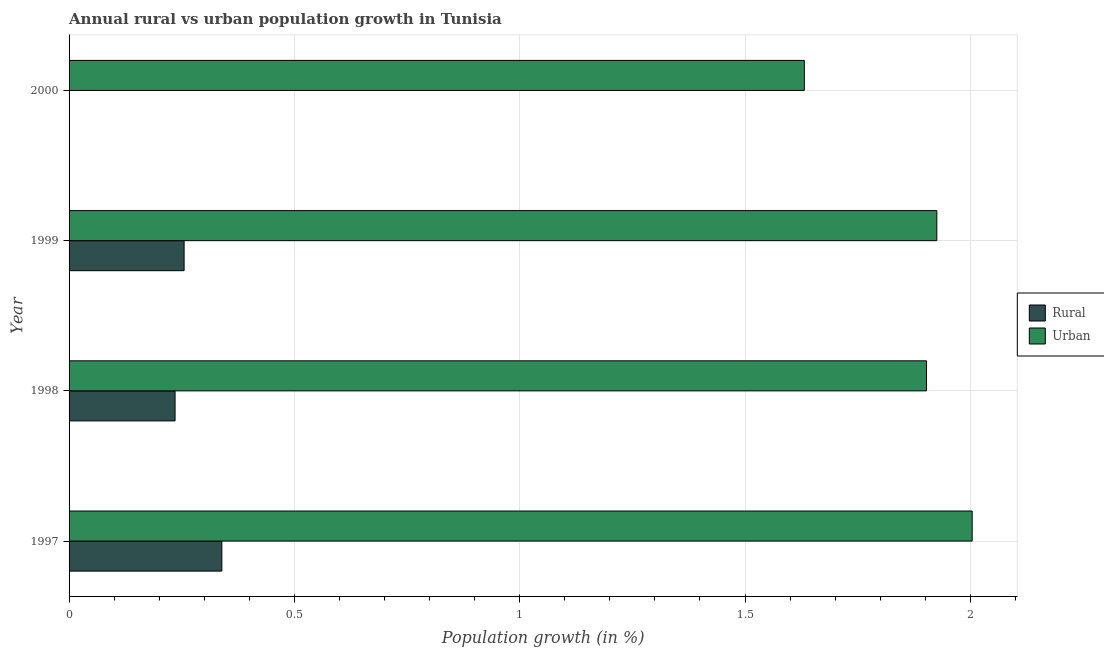Are the number of bars on each tick of the Y-axis equal?
Provide a succinct answer. No. How many bars are there on the 4th tick from the top?
Your answer should be very brief. 2. What is the rural population growth in 1999?
Your response must be concise. 0.26. Across all years, what is the maximum urban population growth?
Keep it short and to the point. 2. In which year was the rural population growth maximum?
Your answer should be compact. 1997. What is the total urban population growth in the graph?
Ensure brevity in your answer.  7.46. What is the difference between the urban population growth in 1998 and that in 1999?
Offer a terse response. -0.02. What is the difference between the urban population growth in 2000 and the rural population growth in 1999?
Make the answer very short. 1.38. What is the average rural population growth per year?
Ensure brevity in your answer.  0.21. In the year 1998, what is the difference between the urban population growth and rural population growth?
Give a very brief answer. 1.67. What is the ratio of the rural population growth in 1997 to that in 1998?
Give a very brief answer. 1.44. Is the urban population growth in 1998 less than that in 2000?
Offer a terse response. No. What is the difference between the highest and the second highest urban population growth?
Offer a very short reply. 0.08. What is the difference between the highest and the lowest urban population growth?
Make the answer very short. 0.37. How many years are there in the graph?
Your response must be concise. 4. Are the values on the major ticks of X-axis written in scientific E-notation?
Offer a terse response. No. Does the graph contain any zero values?
Keep it short and to the point. Yes. Does the graph contain grids?
Your answer should be compact. Yes. Where does the legend appear in the graph?
Ensure brevity in your answer.  Center right. How many legend labels are there?
Make the answer very short. 2. How are the legend labels stacked?
Your answer should be compact. Vertical. What is the title of the graph?
Offer a terse response. Annual rural vs urban population growth in Tunisia. Does "Lowest 20% of population" appear as one of the legend labels in the graph?
Provide a short and direct response. No. What is the label or title of the X-axis?
Your answer should be compact. Population growth (in %). What is the Population growth (in %) in Rural in 1997?
Offer a terse response. 0.34. What is the Population growth (in %) in Urban  in 1997?
Ensure brevity in your answer.  2. What is the Population growth (in %) of Rural in 1998?
Provide a succinct answer. 0.24. What is the Population growth (in %) of Urban  in 1998?
Ensure brevity in your answer.  1.9. What is the Population growth (in %) in Rural in 1999?
Your answer should be compact. 0.26. What is the Population growth (in %) in Urban  in 1999?
Make the answer very short. 1.93. What is the Population growth (in %) in Rural in 2000?
Ensure brevity in your answer.  0. What is the Population growth (in %) in Urban  in 2000?
Provide a short and direct response. 1.63. Across all years, what is the maximum Population growth (in %) in Rural?
Provide a succinct answer. 0.34. Across all years, what is the maximum Population growth (in %) in Urban ?
Keep it short and to the point. 2. Across all years, what is the minimum Population growth (in %) in Urban ?
Provide a succinct answer. 1.63. What is the total Population growth (in %) of Rural in the graph?
Ensure brevity in your answer.  0.83. What is the total Population growth (in %) in Urban  in the graph?
Give a very brief answer. 7.46. What is the difference between the Population growth (in %) in Rural in 1997 and that in 1998?
Offer a terse response. 0.1. What is the difference between the Population growth (in %) in Urban  in 1997 and that in 1998?
Provide a succinct answer. 0.1. What is the difference between the Population growth (in %) of Rural in 1997 and that in 1999?
Ensure brevity in your answer.  0.08. What is the difference between the Population growth (in %) in Urban  in 1997 and that in 1999?
Ensure brevity in your answer.  0.08. What is the difference between the Population growth (in %) in Urban  in 1997 and that in 2000?
Provide a short and direct response. 0.37. What is the difference between the Population growth (in %) of Rural in 1998 and that in 1999?
Your response must be concise. -0.02. What is the difference between the Population growth (in %) in Urban  in 1998 and that in 1999?
Ensure brevity in your answer.  -0.02. What is the difference between the Population growth (in %) in Urban  in 1998 and that in 2000?
Your answer should be very brief. 0.27. What is the difference between the Population growth (in %) in Urban  in 1999 and that in 2000?
Make the answer very short. 0.29. What is the difference between the Population growth (in %) of Rural in 1997 and the Population growth (in %) of Urban  in 1998?
Offer a terse response. -1.56. What is the difference between the Population growth (in %) in Rural in 1997 and the Population growth (in %) in Urban  in 1999?
Make the answer very short. -1.59. What is the difference between the Population growth (in %) of Rural in 1997 and the Population growth (in %) of Urban  in 2000?
Make the answer very short. -1.29. What is the difference between the Population growth (in %) of Rural in 1998 and the Population growth (in %) of Urban  in 1999?
Keep it short and to the point. -1.69. What is the difference between the Population growth (in %) in Rural in 1998 and the Population growth (in %) in Urban  in 2000?
Provide a short and direct response. -1.4. What is the difference between the Population growth (in %) in Rural in 1999 and the Population growth (in %) in Urban  in 2000?
Your answer should be very brief. -1.38. What is the average Population growth (in %) in Rural per year?
Offer a terse response. 0.21. What is the average Population growth (in %) in Urban  per year?
Keep it short and to the point. 1.87. In the year 1997, what is the difference between the Population growth (in %) of Rural and Population growth (in %) of Urban ?
Provide a short and direct response. -1.67. In the year 1998, what is the difference between the Population growth (in %) in Rural and Population growth (in %) in Urban ?
Provide a succinct answer. -1.67. In the year 1999, what is the difference between the Population growth (in %) in Rural and Population growth (in %) in Urban ?
Your answer should be compact. -1.67. What is the ratio of the Population growth (in %) in Rural in 1997 to that in 1998?
Your answer should be very brief. 1.44. What is the ratio of the Population growth (in %) in Urban  in 1997 to that in 1998?
Offer a very short reply. 1.05. What is the ratio of the Population growth (in %) in Rural in 1997 to that in 1999?
Provide a succinct answer. 1.33. What is the ratio of the Population growth (in %) in Urban  in 1997 to that in 1999?
Ensure brevity in your answer.  1.04. What is the ratio of the Population growth (in %) of Urban  in 1997 to that in 2000?
Offer a very short reply. 1.23. What is the ratio of the Population growth (in %) in Rural in 1998 to that in 1999?
Ensure brevity in your answer.  0.92. What is the ratio of the Population growth (in %) of Urban  in 1998 to that in 1999?
Keep it short and to the point. 0.99. What is the ratio of the Population growth (in %) of Urban  in 1998 to that in 2000?
Make the answer very short. 1.17. What is the ratio of the Population growth (in %) of Urban  in 1999 to that in 2000?
Offer a very short reply. 1.18. What is the difference between the highest and the second highest Population growth (in %) of Rural?
Your answer should be very brief. 0.08. What is the difference between the highest and the second highest Population growth (in %) of Urban ?
Provide a succinct answer. 0.08. What is the difference between the highest and the lowest Population growth (in %) in Rural?
Offer a very short reply. 0.34. What is the difference between the highest and the lowest Population growth (in %) in Urban ?
Your answer should be compact. 0.37. 